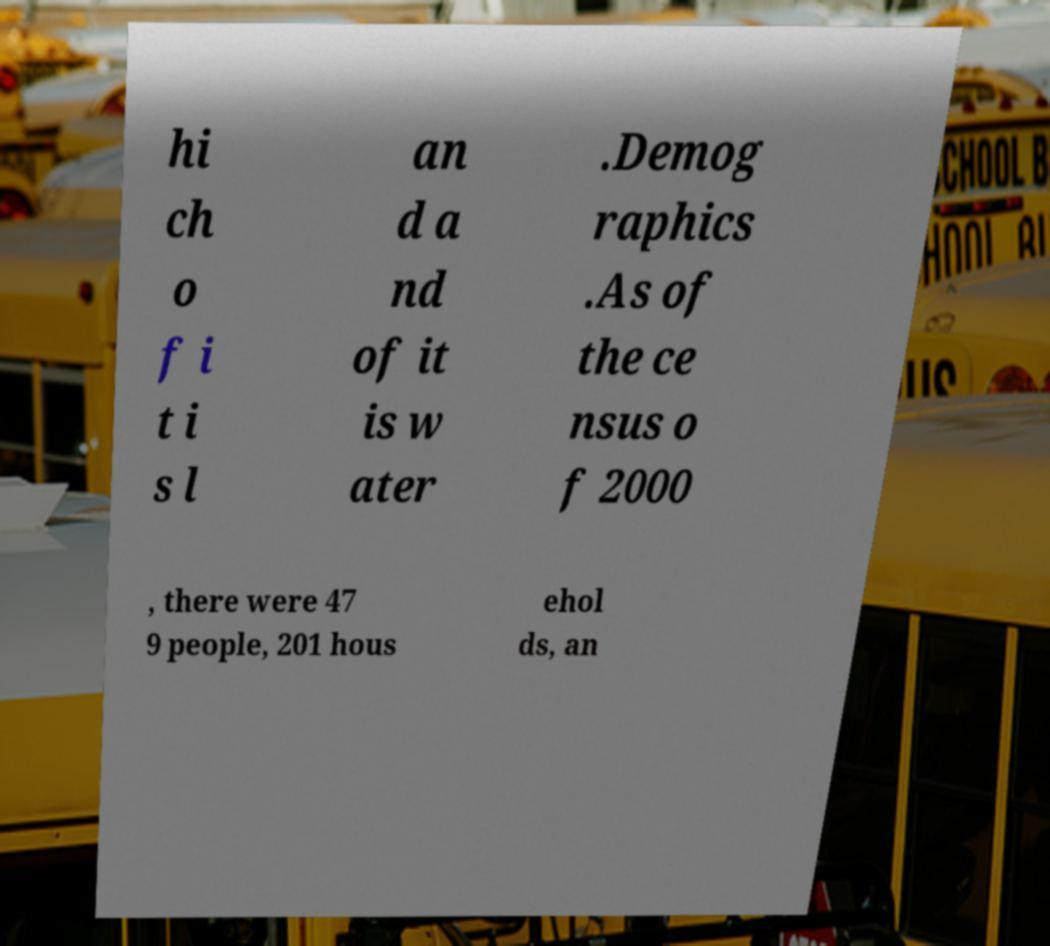Could you extract and type out the text from this image? hi ch o f i t i s l an d a nd of it is w ater .Demog raphics .As of the ce nsus o f 2000 , there were 47 9 people, 201 hous ehol ds, an 